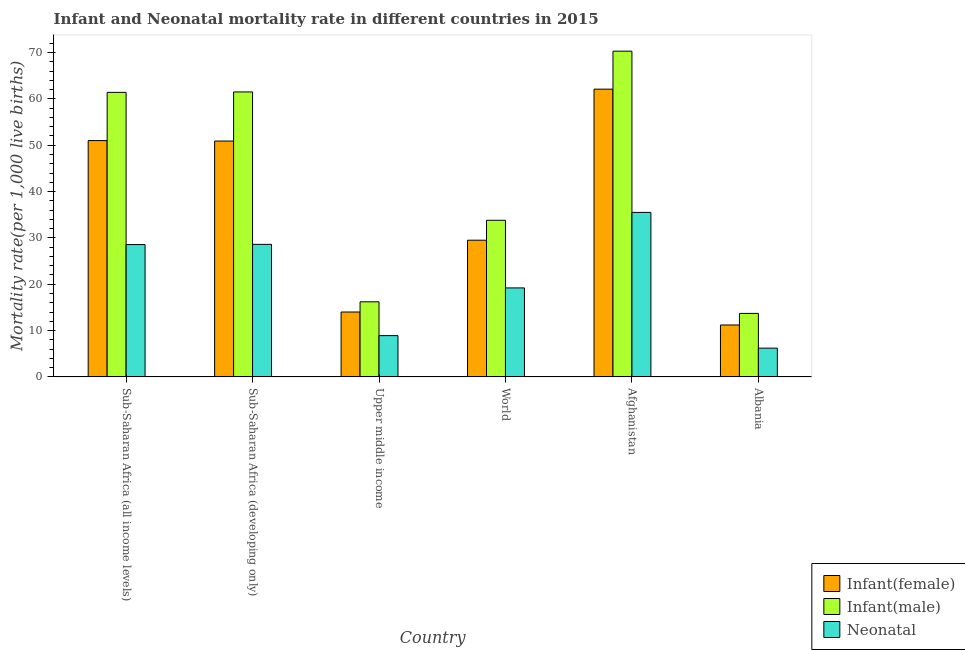Are the number of bars per tick equal to the number of legend labels?
Provide a succinct answer. Yes. Are the number of bars on each tick of the X-axis equal?
Your answer should be very brief. Yes. How many bars are there on the 6th tick from the right?
Offer a very short reply. 3. What is the label of the 6th group of bars from the left?
Your answer should be compact. Albania. What is the infant mortality rate(male) in Sub-Saharan Africa (all income levels)?
Provide a short and direct response. 61.41. Across all countries, what is the maximum infant mortality rate(male)?
Ensure brevity in your answer.  70.3. Across all countries, what is the minimum infant mortality rate(female)?
Provide a succinct answer. 11.2. In which country was the infant mortality rate(female) maximum?
Provide a succinct answer. Afghanistan. In which country was the neonatal mortality rate minimum?
Keep it short and to the point. Albania. What is the total infant mortality rate(male) in the graph?
Provide a succinct answer. 256.91. What is the difference between the infant mortality rate(male) in Afghanistan and that in Upper middle income?
Offer a very short reply. 54.1. What is the difference between the infant mortality rate(male) in Sub-Saharan Africa (all income levels) and the infant mortality rate(female) in Albania?
Your answer should be very brief. 50.21. What is the average infant mortality rate(male) per country?
Give a very brief answer. 42.82. What is the difference between the infant mortality rate(female) and neonatal mortality rate in Afghanistan?
Make the answer very short. 26.6. In how many countries, is the infant mortality rate(female) greater than 18 ?
Offer a terse response. 4. What is the ratio of the infant mortality rate(female) in Afghanistan to that in Albania?
Your response must be concise. 5.54. Is the difference between the infant mortality rate(male) in Sub-Saharan Africa (developing only) and Upper middle income greater than the difference between the neonatal mortality rate in Sub-Saharan Africa (developing only) and Upper middle income?
Give a very brief answer. Yes. What is the difference between the highest and the second highest infant mortality rate(male)?
Provide a short and direct response. 8.8. What is the difference between the highest and the lowest infant mortality rate(female)?
Make the answer very short. 50.9. What does the 1st bar from the left in Sub-Saharan Africa (all income levels) represents?
Your answer should be very brief. Infant(female). What does the 3rd bar from the right in Albania represents?
Your response must be concise. Infant(female). Is it the case that in every country, the sum of the infant mortality rate(female) and infant mortality rate(male) is greater than the neonatal mortality rate?
Keep it short and to the point. Yes. Are the values on the major ticks of Y-axis written in scientific E-notation?
Give a very brief answer. No. Does the graph contain any zero values?
Your response must be concise. No. How are the legend labels stacked?
Provide a succinct answer. Vertical. What is the title of the graph?
Your answer should be very brief. Infant and Neonatal mortality rate in different countries in 2015. What is the label or title of the X-axis?
Your answer should be very brief. Country. What is the label or title of the Y-axis?
Give a very brief answer. Mortality rate(per 1,0 live births). What is the Mortality rate(per 1,000 live births) in Infant(female) in Sub-Saharan Africa (all income levels)?
Your answer should be compact. 51. What is the Mortality rate(per 1,000 live births) in Infant(male) in Sub-Saharan Africa (all income levels)?
Your answer should be very brief. 61.41. What is the Mortality rate(per 1,000 live births) in Neonatal  in Sub-Saharan Africa (all income levels)?
Your answer should be compact. 28.56. What is the Mortality rate(per 1,000 live births) in Infant(female) in Sub-Saharan Africa (developing only)?
Your answer should be very brief. 50.9. What is the Mortality rate(per 1,000 live births) of Infant(male) in Sub-Saharan Africa (developing only)?
Your response must be concise. 61.5. What is the Mortality rate(per 1,000 live births) in Neonatal  in Sub-Saharan Africa (developing only)?
Your answer should be very brief. 28.6. What is the Mortality rate(per 1,000 live births) of Infant(male) in Upper middle income?
Make the answer very short. 16.2. What is the Mortality rate(per 1,000 live births) in Neonatal  in Upper middle income?
Offer a terse response. 8.9. What is the Mortality rate(per 1,000 live births) of Infant(female) in World?
Your response must be concise. 29.5. What is the Mortality rate(per 1,000 live births) in Infant(male) in World?
Keep it short and to the point. 33.8. What is the Mortality rate(per 1,000 live births) of Neonatal  in World?
Provide a succinct answer. 19.2. What is the Mortality rate(per 1,000 live births) of Infant(female) in Afghanistan?
Provide a succinct answer. 62.1. What is the Mortality rate(per 1,000 live births) of Infant(male) in Afghanistan?
Your response must be concise. 70.3. What is the Mortality rate(per 1,000 live births) of Neonatal  in Afghanistan?
Your response must be concise. 35.5. What is the Mortality rate(per 1,000 live births) in Infant(female) in Albania?
Keep it short and to the point. 11.2. Across all countries, what is the maximum Mortality rate(per 1,000 live births) of Infant(female)?
Your response must be concise. 62.1. Across all countries, what is the maximum Mortality rate(per 1,000 live births) in Infant(male)?
Your response must be concise. 70.3. Across all countries, what is the maximum Mortality rate(per 1,000 live births) in Neonatal ?
Offer a terse response. 35.5. Across all countries, what is the minimum Mortality rate(per 1,000 live births) in Infant(female)?
Provide a short and direct response. 11.2. Across all countries, what is the minimum Mortality rate(per 1,000 live births) in Infant(male)?
Make the answer very short. 13.7. Across all countries, what is the minimum Mortality rate(per 1,000 live births) of Neonatal ?
Provide a short and direct response. 6.2. What is the total Mortality rate(per 1,000 live births) of Infant(female) in the graph?
Your answer should be compact. 218.7. What is the total Mortality rate(per 1,000 live births) in Infant(male) in the graph?
Keep it short and to the point. 256.91. What is the total Mortality rate(per 1,000 live births) of Neonatal  in the graph?
Provide a short and direct response. 126.96. What is the difference between the Mortality rate(per 1,000 live births) of Infant(female) in Sub-Saharan Africa (all income levels) and that in Sub-Saharan Africa (developing only)?
Your answer should be compact. 0.1. What is the difference between the Mortality rate(per 1,000 live births) of Infant(male) in Sub-Saharan Africa (all income levels) and that in Sub-Saharan Africa (developing only)?
Your response must be concise. -0.09. What is the difference between the Mortality rate(per 1,000 live births) of Neonatal  in Sub-Saharan Africa (all income levels) and that in Sub-Saharan Africa (developing only)?
Your response must be concise. -0.04. What is the difference between the Mortality rate(per 1,000 live births) in Infant(female) in Sub-Saharan Africa (all income levels) and that in Upper middle income?
Ensure brevity in your answer.  37. What is the difference between the Mortality rate(per 1,000 live births) in Infant(male) in Sub-Saharan Africa (all income levels) and that in Upper middle income?
Offer a terse response. 45.21. What is the difference between the Mortality rate(per 1,000 live births) of Neonatal  in Sub-Saharan Africa (all income levels) and that in Upper middle income?
Make the answer very short. 19.66. What is the difference between the Mortality rate(per 1,000 live births) of Infant(female) in Sub-Saharan Africa (all income levels) and that in World?
Provide a short and direct response. 21.5. What is the difference between the Mortality rate(per 1,000 live births) of Infant(male) in Sub-Saharan Africa (all income levels) and that in World?
Offer a terse response. 27.61. What is the difference between the Mortality rate(per 1,000 live births) in Neonatal  in Sub-Saharan Africa (all income levels) and that in World?
Provide a short and direct response. 9.36. What is the difference between the Mortality rate(per 1,000 live births) in Infant(female) in Sub-Saharan Africa (all income levels) and that in Afghanistan?
Your response must be concise. -11.1. What is the difference between the Mortality rate(per 1,000 live births) in Infant(male) in Sub-Saharan Africa (all income levels) and that in Afghanistan?
Keep it short and to the point. -8.89. What is the difference between the Mortality rate(per 1,000 live births) of Neonatal  in Sub-Saharan Africa (all income levels) and that in Afghanistan?
Your answer should be very brief. -6.94. What is the difference between the Mortality rate(per 1,000 live births) in Infant(female) in Sub-Saharan Africa (all income levels) and that in Albania?
Offer a terse response. 39.8. What is the difference between the Mortality rate(per 1,000 live births) of Infant(male) in Sub-Saharan Africa (all income levels) and that in Albania?
Give a very brief answer. 47.71. What is the difference between the Mortality rate(per 1,000 live births) in Neonatal  in Sub-Saharan Africa (all income levels) and that in Albania?
Ensure brevity in your answer.  22.36. What is the difference between the Mortality rate(per 1,000 live births) of Infant(female) in Sub-Saharan Africa (developing only) and that in Upper middle income?
Your response must be concise. 36.9. What is the difference between the Mortality rate(per 1,000 live births) in Infant(male) in Sub-Saharan Africa (developing only) and that in Upper middle income?
Your response must be concise. 45.3. What is the difference between the Mortality rate(per 1,000 live births) of Neonatal  in Sub-Saharan Africa (developing only) and that in Upper middle income?
Provide a short and direct response. 19.7. What is the difference between the Mortality rate(per 1,000 live births) of Infant(female) in Sub-Saharan Africa (developing only) and that in World?
Give a very brief answer. 21.4. What is the difference between the Mortality rate(per 1,000 live births) in Infant(male) in Sub-Saharan Africa (developing only) and that in World?
Provide a short and direct response. 27.7. What is the difference between the Mortality rate(per 1,000 live births) in Infant(female) in Sub-Saharan Africa (developing only) and that in Afghanistan?
Provide a short and direct response. -11.2. What is the difference between the Mortality rate(per 1,000 live births) of Infant(male) in Sub-Saharan Africa (developing only) and that in Afghanistan?
Offer a terse response. -8.8. What is the difference between the Mortality rate(per 1,000 live births) in Infant(female) in Sub-Saharan Africa (developing only) and that in Albania?
Your response must be concise. 39.7. What is the difference between the Mortality rate(per 1,000 live births) of Infant(male) in Sub-Saharan Africa (developing only) and that in Albania?
Your answer should be compact. 47.8. What is the difference between the Mortality rate(per 1,000 live births) of Neonatal  in Sub-Saharan Africa (developing only) and that in Albania?
Offer a very short reply. 22.4. What is the difference between the Mortality rate(per 1,000 live births) in Infant(female) in Upper middle income and that in World?
Provide a short and direct response. -15.5. What is the difference between the Mortality rate(per 1,000 live births) of Infant(male) in Upper middle income and that in World?
Make the answer very short. -17.6. What is the difference between the Mortality rate(per 1,000 live births) in Neonatal  in Upper middle income and that in World?
Your response must be concise. -10.3. What is the difference between the Mortality rate(per 1,000 live births) in Infant(female) in Upper middle income and that in Afghanistan?
Your answer should be very brief. -48.1. What is the difference between the Mortality rate(per 1,000 live births) in Infant(male) in Upper middle income and that in Afghanistan?
Your response must be concise. -54.1. What is the difference between the Mortality rate(per 1,000 live births) in Neonatal  in Upper middle income and that in Afghanistan?
Ensure brevity in your answer.  -26.6. What is the difference between the Mortality rate(per 1,000 live births) in Infant(female) in Upper middle income and that in Albania?
Offer a terse response. 2.8. What is the difference between the Mortality rate(per 1,000 live births) of Infant(male) in Upper middle income and that in Albania?
Your answer should be compact. 2.5. What is the difference between the Mortality rate(per 1,000 live births) in Neonatal  in Upper middle income and that in Albania?
Keep it short and to the point. 2.7. What is the difference between the Mortality rate(per 1,000 live births) in Infant(female) in World and that in Afghanistan?
Provide a short and direct response. -32.6. What is the difference between the Mortality rate(per 1,000 live births) of Infant(male) in World and that in Afghanistan?
Offer a terse response. -36.5. What is the difference between the Mortality rate(per 1,000 live births) of Neonatal  in World and that in Afghanistan?
Your answer should be very brief. -16.3. What is the difference between the Mortality rate(per 1,000 live births) in Infant(male) in World and that in Albania?
Offer a very short reply. 20.1. What is the difference between the Mortality rate(per 1,000 live births) of Infant(female) in Afghanistan and that in Albania?
Offer a very short reply. 50.9. What is the difference between the Mortality rate(per 1,000 live births) of Infant(male) in Afghanistan and that in Albania?
Provide a short and direct response. 56.6. What is the difference between the Mortality rate(per 1,000 live births) in Neonatal  in Afghanistan and that in Albania?
Provide a succinct answer. 29.3. What is the difference between the Mortality rate(per 1,000 live births) in Infant(female) in Sub-Saharan Africa (all income levels) and the Mortality rate(per 1,000 live births) in Infant(male) in Sub-Saharan Africa (developing only)?
Keep it short and to the point. -10.5. What is the difference between the Mortality rate(per 1,000 live births) of Infant(female) in Sub-Saharan Africa (all income levels) and the Mortality rate(per 1,000 live births) of Neonatal  in Sub-Saharan Africa (developing only)?
Offer a very short reply. 22.4. What is the difference between the Mortality rate(per 1,000 live births) of Infant(male) in Sub-Saharan Africa (all income levels) and the Mortality rate(per 1,000 live births) of Neonatal  in Sub-Saharan Africa (developing only)?
Offer a very short reply. 32.81. What is the difference between the Mortality rate(per 1,000 live births) in Infant(female) in Sub-Saharan Africa (all income levels) and the Mortality rate(per 1,000 live births) in Infant(male) in Upper middle income?
Keep it short and to the point. 34.8. What is the difference between the Mortality rate(per 1,000 live births) in Infant(female) in Sub-Saharan Africa (all income levels) and the Mortality rate(per 1,000 live births) in Neonatal  in Upper middle income?
Ensure brevity in your answer.  42.1. What is the difference between the Mortality rate(per 1,000 live births) in Infant(male) in Sub-Saharan Africa (all income levels) and the Mortality rate(per 1,000 live births) in Neonatal  in Upper middle income?
Make the answer very short. 52.51. What is the difference between the Mortality rate(per 1,000 live births) in Infant(female) in Sub-Saharan Africa (all income levels) and the Mortality rate(per 1,000 live births) in Infant(male) in World?
Your answer should be compact. 17.2. What is the difference between the Mortality rate(per 1,000 live births) of Infant(female) in Sub-Saharan Africa (all income levels) and the Mortality rate(per 1,000 live births) of Neonatal  in World?
Keep it short and to the point. 31.8. What is the difference between the Mortality rate(per 1,000 live births) of Infant(male) in Sub-Saharan Africa (all income levels) and the Mortality rate(per 1,000 live births) of Neonatal  in World?
Provide a succinct answer. 42.21. What is the difference between the Mortality rate(per 1,000 live births) in Infant(female) in Sub-Saharan Africa (all income levels) and the Mortality rate(per 1,000 live births) in Infant(male) in Afghanistan?
Keep it short and to the point. -19.3. What is the difference between the Mortality rate(per 1,000 live births) in Infant(female) in Sub-Saharan Africa (all income levels) and the Mortality rate(per 1,000 live births) in Neonatal  in Afghanistan?
Your answer should be compact. 15.5. What is the difference between the Mortality rate(per 1,000 live births) in Infant(male) in Sub-Saharan Africa (all income levels) and the Mortality rate(per 1,000 live births) in Neonatal  in Afghanistan?
Provide a short and direct response. 25.91. What is the difference between the Mortality rate(per 1,000 live births) of Infant(female) in Sub-Saharan Africa (all income levels) and the Mortality rate(per 1,000 live births) of Infant(male) in Albania?
Keep it short and to the point. 37.3. What is the difference between the Mortality rate(per 1,000 live births) in Infant(female) in Sub-Saharan Africa (all income levels) and the Mortality rate(per 1,000 live births) in Neonatal  in Albania?
Keep it short and to the point. 44.8. What is the difference between the Mortality rate(per 1,000 live births) in Infant(male) in Sub-Saharan Africa (all income levels) and the Mortality rate(per 1,000 live births) in Neonatal  in Albania?
Your response must be concise. 55.21. What is the difference between the Mortality rate(per 1,000 live births) of Infant(female) in Sub-Saharan Africa (developing only) and the Mortality rate(per 1,000 live births) of Infant(male) in Upper middle income?
Your answer should be compact. 34.7. What is the difference between the Mortality rate(per 1,000 live births) of Infant(male) in Sub-Saharan Africa (developing only) and the Mortality rate(per 1,000 live births) of Neonatal  in Upper middle income?
Make the answer very short. 52.6. What is the difference between the Mortality rate(per 1,000 live births) of Infant(female) in Sub-Saharan Africa (developing only) and the Mortality rate(per 1,000 live births) of Neonatal  in World?
Keep it short and to the point. 31.7. What is the difference between the Mortality rate(per 1,000 live births) of Infant(male) in Sub-Saharan Africa (developing only) and the Mortality rate(per 1,000 live births) of Neonatal  in World?
Your answer should be very brief. 42.3. What is the difference between the Mortality rate(per 1,000 live births) in Infant(female) in Sub-Saharan Africa (developing only) and the Mortality rate(per 1,000 live births) in Infant(male) in Afghanistan?
Your response must be concise. -19.4. What is the difference between the Mortality rate(per 1,000 live births) of Infant(female) in Sub-Saharan Africa (developing only) and the Mortality rate(per 1,000 live births) of Neonatal  in Afghanistan?
Keep it short and to the point. 15.4. What is the difference between the Mortality rate(per 1,000 live births) in Infant(female) in Sub-Saharan Africa (developing only) and the Mortality rate(per 1,000 live births) in Infant(male) in Albania?
Your response must be concise. 37.2. What is the difference between the Mortality rate(per 1,000 live births) in Infant(female) in Sub-Saharan Africa (developing only) and the Mortality rate(per 1,000 live births) in Neonatal  in Albania?
Keep it short and to the point. 44.7. What is the difference between the Mortality rate(per 1,000 live births) in Infant(male) in Sub-Saharan Africa (developing only) and the Mortality rate(per 1,000 live births) in Neonatal  in Albania?
Ensure brevity in your answer.  55.3. What is the difference between the Mortality rate(per 1,000 live births) in Infant(female) in Upper middle income and the Mortality rate(per 1,000 live births) in Infant(male) in World?
Ensure brevity in your answer.  -19.8. What is the difference between the Mortality rate(per 1,000 live births) of Infant(male) in Upper middle income and the Mortality rate(per 1,000 live births) of Neonatal  in World?
Your answer should be compact. -3. What is the difference between the Mortality rate(per 1,000 live births) of Infant(female) in Upper middle income and the Mortality rate(per 1,000 live births) of Infant(male) in Afghanistan?
Give a very brief answer. -56.3. What is the difference between the Mortality rate(per 1,000 live births) of Infant(female) in Upper middle income and the Mortality rate(per 1,000 live births) of Neonatal  in Afghanistan?
Provide a short and direct response. -21.5. What is the difference between the Mortality rate(per 1,000 live births) of Infant(male) in Upper middle income and the Mortality rate(per 1,000 live births) of Neonatal  in Afghanistan?
Your response must be concise. -19.3. What is the difference between the Mortality rate(per 1,000 live births) in Infant(female) in Upper middle income and the Mortality rate(per 1,000 live births) in Infant(male) in Albania?
Offer a terse response. 0.3. What is the difference between the Mortality rate(per 1,000 live births) of Infant(female) in Upper middle income and the Mortality rate(per 1,000 live births) of Neonatal  in Albania?
Offer a very short reply. 7.8. What is the difference between the Mortality rate(per 1,000 live births) in Infant(female) in World and the Mortality rate(per 1,000 live births) in Infant(male) in Afghanistan?
Your answer should be compact. -40.8. What is the difference between the Mortality rate(per 1,000 live births) of Infant(male) in World and the Mortality rate(per 1,000 live births) of Neonatal  in Afghanistan?
Offer a terse response. -1.7. What is the difference between the Mortality rate(per 1,000 live births) of Infant(female) in World and the Mortality rate(per 1,000 live births) of Infant(male) in Albania?
Your answer should be very brief. 15.8. What is the difference between the Mortality rate(per 1,000 live births) in Infant(female) in World and the Mortality rate(per 1,000 live births) in Neonatal  in Albania?
Provide a succinct answer. 23.3. What is the difference between the Mortality rate(per 1,000 live births) of Infant(male) in World and the Mortality rate(per 1,000 live births) of Neonatal  in Albania?
Offer a very short reply. 27.6. What is the difference between the Mortality rate(per 1,000 live births) in Infant(female) in Afghanistan and the Mortality rate(per 1,000 live births) in Infant(male) in Albania?
Provide a short and direct response. 48.4. What is the difference between the Mortality rate(per 1,000 live births) in Infant(female) in Afghanistan and the Mortality rate(per 1,000 live births) in Neonatal  in Albania?
Make the answer very short. 55.9. What is the difference between the Mortality rate(per 1,000 live births) in Infant(male) in Afghanistan and the Mortality rate(per 1,000 live births) in Neonatal  in Albania?
Keep it short and to the point. 64.1. What is the average Mortality rate(per 1,000 live births) in Infant(female) per country?
Give a very brief answer. 36.45. What is the average Mortality rate(per 1,000 live births) of Infant(male) per country?
Give a very brief answer. 42.82. What is the average Mortality rate(per 1,000 live births) of Neonatal  per country?
Ensure brevity in your answer.  21.16. What is the difference between the Mortality rate(per 1,000 live births) of Infant(female) and Mortality rate(per 1,000 live births) of Infant(male) in Sub-Saharan Africa (all income levels)?
Give a very brief answer. -10.41. What is the difference between the Mortality rate(per 1,000 live births) in Infant(female) and Mortality rate(per 1,000 live births) in Neonatal  in Sub-Saharan Africa (all income levels)?
Offer a terse response. 22.44. What is the difference between the Mortality rate(per 1,000 live births) of Infant(male) and Mortality rate(per 1,000 live births) of Neonatal  in Sub-Saharan Africa (all income levels)?
Offer a terse response. 32.85. What is the difference between the Mortality rate(per 1,000 live births) of Infant(female) and Mortality rate(per 1,000 live births) of Neonatal  in Sub-Saharan Africa (developing only)?
Your answer should be very brief. 22.3. What is the difference between the Mortality rate(per 1,000 live births) of Infant(male) and Mortality rate(per 1,000 live births) of Neonatal  in Sub-Saharan Africa (developing only)?
Make the answer very short. 32.9. What is the difference between the Mortality rate(per 1,000 live births) in Infant(female) and Mortality rate(per 1,000 live births) in Infant(male) in World?
Your response must be concise. -4.3. What is the difference between the Mortality rate(per 1,000 live births) of Infant(female) and Mortality rate(per 1,000 live births) of Infant(male) in Afghanistan?
Offer a very short reply. -8.2. What is the difference between the Mortality rate(per 1,000 live births) in Infant(female) and Mortality rate(per 1,000 live births) in Neonatal  in Afghanistan?
Your response must be concise. 26.6. What is the difference between the Mortality rate(per 1,000 live births) in Infant(male) and Mortality rate(per 1,000 live births) in Neonatal  in Afghanistan?
Keep it short and to the point. 34.8. What is the difference between the Mortality rate(per 1,000 live births) in Infant(female) and Mortality rate(per 1,000 live births) in Infant(male) in Albania?
Your answer should be very brief. -2.5. What is the difference between the Mortality rate(per 1,000 live births) of Infant(male) and Mortality rate(per 1,000 live births) of Neonatal  in Albania?
Provide a short and direct response. 7.5. What is the ratio of the Mortality rate(per 1,000 live births) of Infant(female) in Sub-Saharan Africa (all income levels) to that in Upper middle income?
Keep it short and to the point. 3.64. What is the ratio of the Mortality rate(per 1,000 live births) in Infant(male) in Sub-Saharan Africa (all income levels) to that in Upper middle income?
Provide a succinct answer. 3.79. What is the ratio of the Mortality rate(per 1,000 live births) in Neonatal  in Sub-Saharan Africa (all income levels) to that in Upper middle income?
Make the answer very short. 3.21. What is the ratio of the Mortality rate(per 1,000 live births) in Infant(female) in Sub-Saharan Africa (all income levels) to that in World?
Offer a terse response. 1.73. What is the ratio of the Mortality rate(per 1,000 live births) in Infant(male) in Sub-Saharan Africa (all income levels) to that in World?
Offer a terse response. 1.82. What is the ratio of the Mortality rate(per 1,000 live births) in Neonatal  in Sub-Saharan Africa (all income levels) to that in World?
Make the answer very short. 1.49. What is the ratio of the Mortality rate(per 1,000 live births) of Infant(female) in Sub-Saharan Africa (all income levels) to that in Afghanistan?
Make the answer very short. 0.82. What is the ratio of the Mortality rate(per 1,000 live births) in Infant(male) in Sub-Saharan Africa (all income levels) to that in Afghanistan?
Offer a terse response. 0.87. What is the ratio of the Mortality rate(per 1,000 live births) of Neonatal  in Sub-Saharan Africa (all income levels) to that in Afghanistan?
Offer a very short reply. 0.8. What is the ratio of the Mortality rate(per 1,000 live births) of Infant(female) in Sub-Saharan Africa (all income levels) to that in Albania?
Your answer should be very brief. 4.55. What is the ratio of the Mortality rate(per 1,000 live births) in Infant(male) in Sub-Saharan Africa (all income levels) to that in Albania?
Ensure brevity in your answer.  4.48. What is the ratio of the Mortality rate(per 1,000 live births) in Neonatal  in Sub-Saharan Africa (all income levels) to that in Albania?
Make the answer very short. 4.61. What is the ratio of the Mortality rate(per 1,000 live births) in Infant(female) in Sub-Saharan Africa (developing only) to that in Upper middle income?
Provide a succinct answer. 3.64. What is the ratio of the Mortality rate(per 1,000 live births) in Infant(male) in Sub-Saharan Africa (developing only) to that in Upper middle income?
Offer a very short reply. 3.8. What is the ratio of the Mortality rate(per 1,000 live births) of Neonatal  in Sub-Saharan Africa (developing only) to that in Upper middle income?
Make the answer very short. 3.21. What is the ratio of the Mortality rate(per 1,000 live births) of Infant(female) in Sub-Saharan Africa (developing only) to that in World?
Ensure brevity in your answer.  1.73. What is the ratio of the Mortality rate(per 1,000 live births) of Infant(male) in Sub-Saharan Africa (developing only) to that in World?
Make the answer very short. 1.82. What is the ratio of the Mortality rate(per 1,000 live births) of Neonatal  in Sub-Saharan Africa (developing only) to that in World?
Your response must be concise. 1.49. What is the ratio of the Mortality rate(per 1,000 live births) of Infant(female) in Sub-Saharan Africa (developing only) to that in Afghanistan?
Keep it short and to the point. 0.82. What is the ratio of the Mortality rate(per 1,000 live births) in Infant(male) in Sub-Saharan Africa (developing only) to that in Afghanistan?
Ensure brevity in your answer.  0.87. What is the ratio of the Mortality rate(per 1,000 live births) in Neonatal  in Sub-Saharan Africa (developing only) to that in Afghanistan?
Keep it short and to the point. 0.81. What is the ratio of the Mortality rate(per 1,000 live births) in Infant(female) in Sub-Saharan Africa (developing only) to that in Albania?
Keep it short and to the point. 4.54. What is the ratio of the Mortality rate(per 1,000 live births) in Infant(male) in Sub-Saharan Africa (developing only) to that in Albania?
Make the answer very short. 4.49. What is the ratio of the Mortality rate(per 1,000 live births) in Neonatal  in Sub-Saharan Africa (developing only) to that in Albania?
Offer a very short reply. 4.61. What is the ratio of the Mortality rate(per 1,000 live births) of Infant(female) in Upper middle income to that in World?
Give a very brief answer. 0.47. What is the ratio of the Mortality rate(per 1,000 live births) of Infant(male) in Upper middle income to that in World?
Make the answer very short. 0.48. What is the ratio of the Mortality rate(per 1,000 live births) of Neonatal  in Upper middle income to that in World?
Offer a terse response. 0.46. What is the ratio of the Mortality rate(per 1,000 live births) in Infant(female) in Upper middle income to that in Afghanistan?
Make the answer very short. 0.23. What is the ratio of the Mortality rate(per 1,000 live births) of Infant(male) in Upper middle income to that in Afghanistan?
Your answer should be very brief. 0.23. What is the ratio of the Mortality rate(per 1,000 live births) of Neonatal  in Upper middle income to that in Afghanistan?
Offer a terse response. 0.25. What is the ratio of the Mortality rate(per 1,000 live births) of Infant(male) in Upper middle income to that in Albania?
Give a very brief answer. 1.18. What is the ratio of the Mortality rate(per 1,000 live births) in Neonatal  in Upper middle income to that in Albania?
Provide a short and direct response. 1.44. What is the ratio of the Mortality rate(per 1,000 live births) in Infant(female) in World to that in Afghanistan?
Provide a succinct answer. 0.47. What is the ratio of the Mortality rate(per 1,000 live births) of Infant(male) in World to that in Afghanistan?
Give a very brief answer. 0.48. What is the ratio of the Mortality rate(per 1,000 live births) in Neonatal  in World to that in Afghanistan?
Your answer should be compact. 0.54. What is the ratio of the Mortality rate(per 1,000 live births) of Infant(female) in World to that in Albania?
Keep it short and to the point. 2.63. What is the ratio of the Mortality rate(per 1,000 live births) in Infant(male) in World to that in Albania?
Provide a succinct answer. 2.47. What is the ratio of the Mortality rate(per 1,000 live births) in Neonatal  in World to that in Albania?
Offer a very short reply. 3.1. What is the ratio of the Mortality rate(per 1,000 live births) in Infant(female) in Afghanistan to that in Albania?
Your response must be concise. 5.54. What is the ratio of the Mortality rate(per 1,000 live births) in Infant(male) in Afghanistan to that in Albania?
Keep it short and to the point. 5.13. What is the ratio of the Mortality rate(per 1,000 live births) in Neonatal  in Afghanistan to that in Albania?
Give a very brief answer. 5.73. What is the difference between the highest and the second highest Mortality rate(per 1,000 live births) in Infant(female)?
Keep it short and to the point. 11.1. What is the difference between the highest and the second highest Mortality rate(per 1,000 live births) of Infant(male)?
Your answer should be compact. 8.8. What is the difference between the highest and the second highest Mortality rate(per 1,000 live births) in Neonatal ?
Your response must be concise. 6.9. What is the difference between the highest and the lowest Mortality rate(per 1,000 live births) in Infant(female)?
Offer a terse response. 50.9. What is the difference between the highest and the lowest Mortality rate(per 1,000 live births) in Infant(male)?
Ensure brevity in your answer.  56.6. What is the difference between the highest and the lowest Mortality rate(per 1,000 live births) of Neonatal ?
Provide a succinct answer. 29.3. 